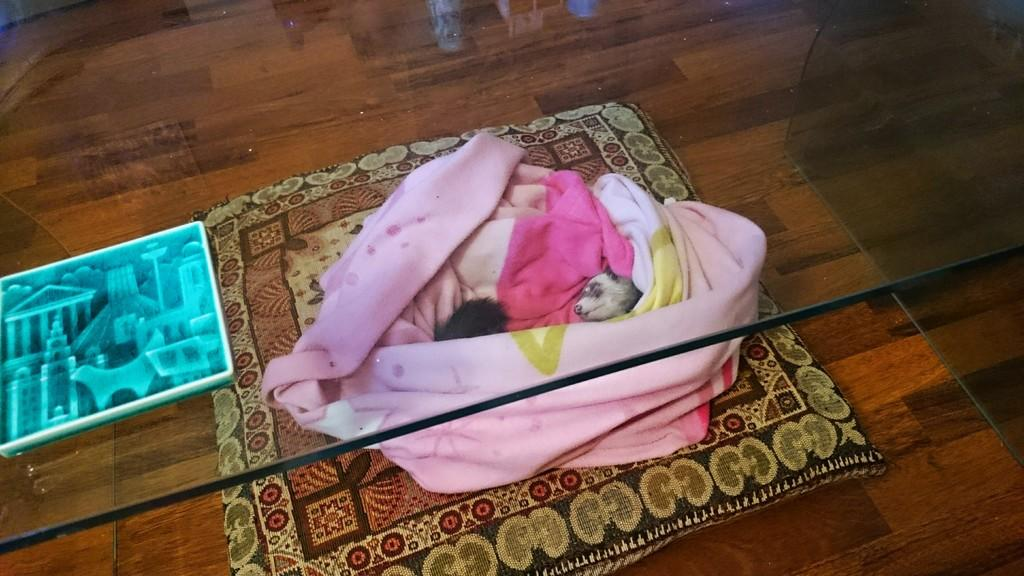What type of animal is in the image? There is an animal in the image, but its specific type is not mentioned in the facts. How is the animal dressed or covered? The animal is in cloth. What is the animal standing or sitting on? The animal is on a carpet. What is another object visible in the image? There is a glass visible in the image. What is on the side in the image? There is a poster on the side in the image. What type of journey is the animal embarking on in the image? There is no indication of a journey in the image; it simply shows an animal in cloth on a carpet. How many copies of the poster are visible in the image? There is no mention of multiple copies of the poster; only one poster is mentioned. 